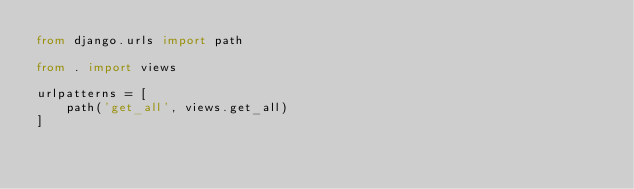Convert code to text. <code><loc_0><loc_0><loc_500><loc_500><_Python_>from django.urls import path

from . import views

urlpatterns = [
    path('get_all', views.get_all)
]</code> 